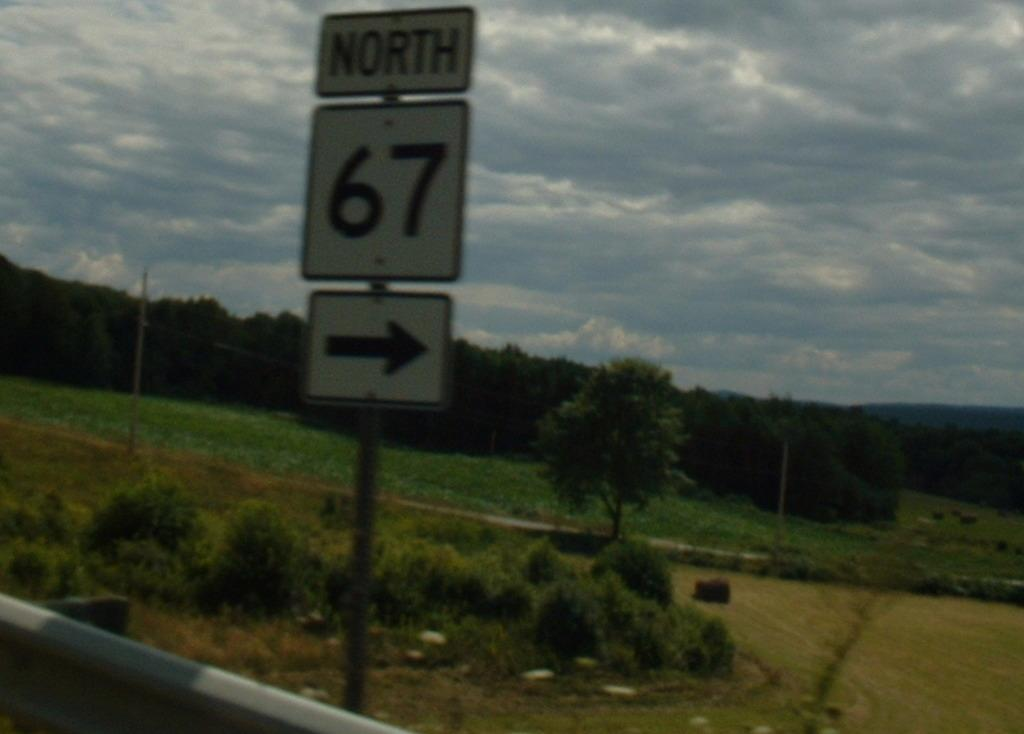<image>
Provide a brief description of the given image. Outside sign on the road telling drivers North 67 is on the right. 